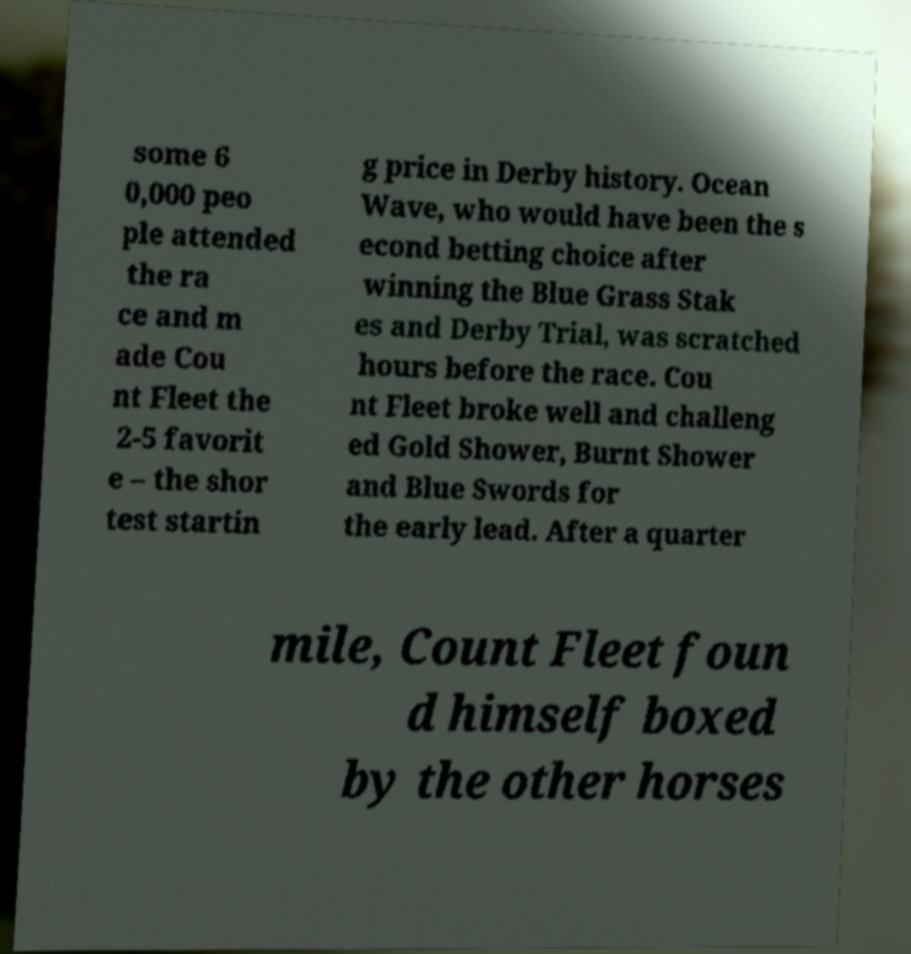What messages or text are displayed in this image? I need them in a readable, typed format. some 6 0,000 peo ple attended the ra ce and m ade Cou nt Fleet the 2-5 favorit e – the shor test startin g price in Derby history. Ocean Wave, who would have been the s econd betting choice after winning the Blue Grass Stak es and Derby Trial, was scratched hours before the race. Cou nt Fleet broke well and challeng ed Gold Shower, Burnt Shower and Blue Swords for the early lead. After a quarter mile, Count Fleet foun d himself boxed by the other horses 